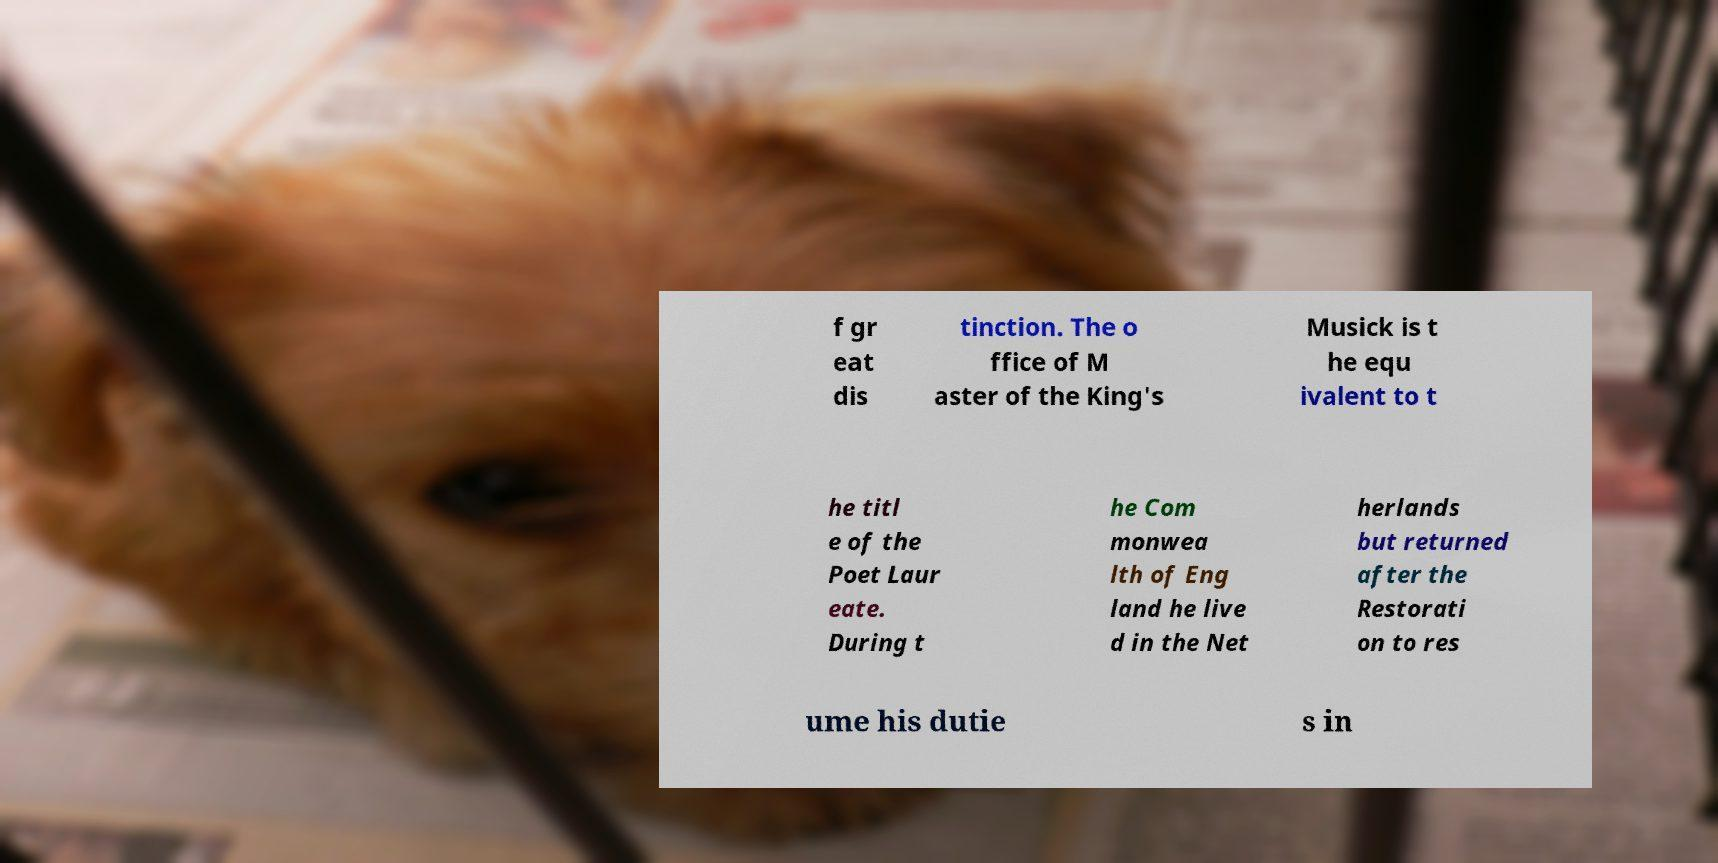Can you read and provide the text displayed in the image?This photo seems to have some interesting text. Can you extract and type it out for me? f gr eat dis tinction. The o ffice of M aster of the King's Musick is t he equ ivalent to t he titl e of the Poet Laur eate. During t he Com monwea lth of Eng land he live d in the Net herlands but returned after the Restorati on to res ume his dutie s in 